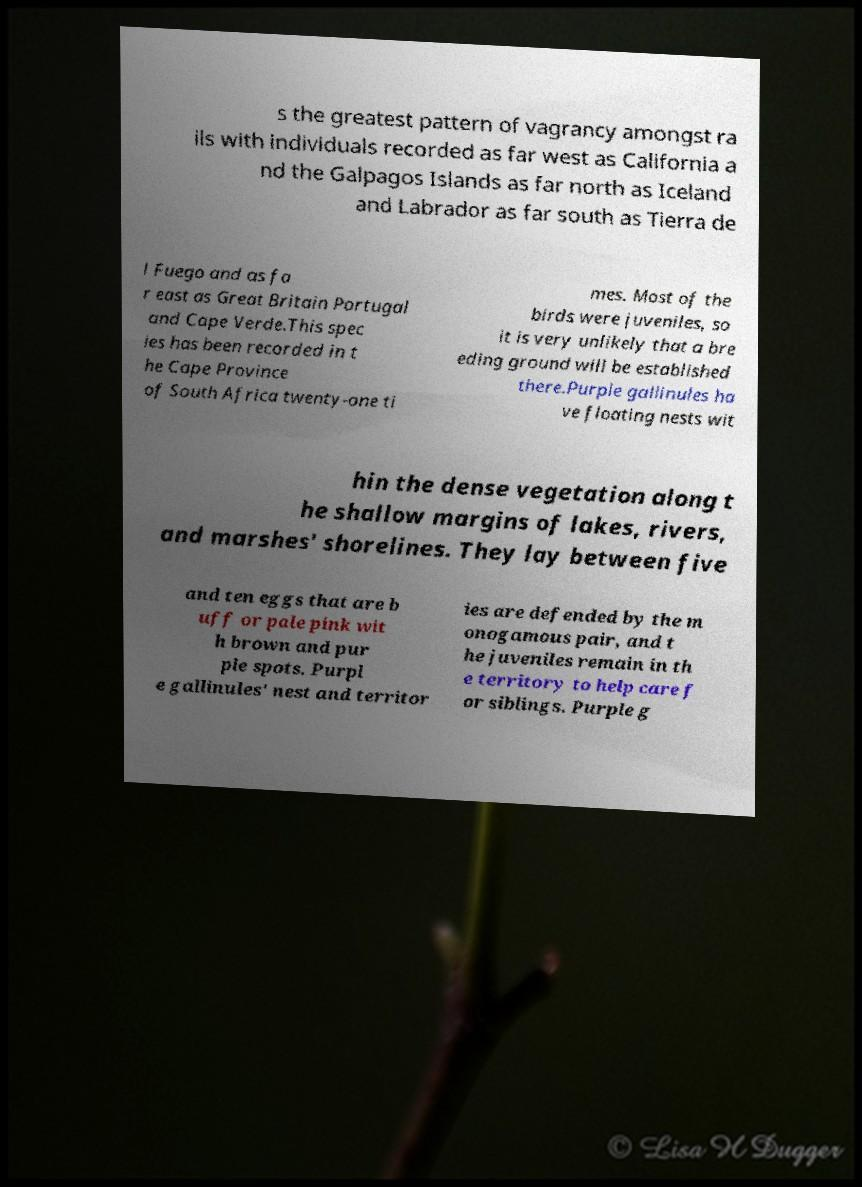I need the written content from this picture converted into text. Can you do that? s the greatest pattern of vagrancy amongst ra ils with individuals recorded as far west as California a nd the Galpagos Islands as far north as Iceland and Labrador as far south as Tierra de l Fuego and as fa r east as Great Britain Portugal and Cape Verde.This spec ies has been recorded in t he Cape Province of South Africa twenty-one ti mes. Most of the birds were juveniles, so it is very unlikely that a bre eding ground will be established there.Purple gallinules ha ve floating nests wit hin the dense vegetation along t he shallow margins of lakes, rivers, and marshes' shorelines. They lay between five and ten eggs that are b uff or pale pink wit h brown and pur ple spots. Purpl e gallinules' nest and territor ies are defended by the m onogamous pair, and t he juveniles remain in th e territory to help care f or siblings. Purple g 